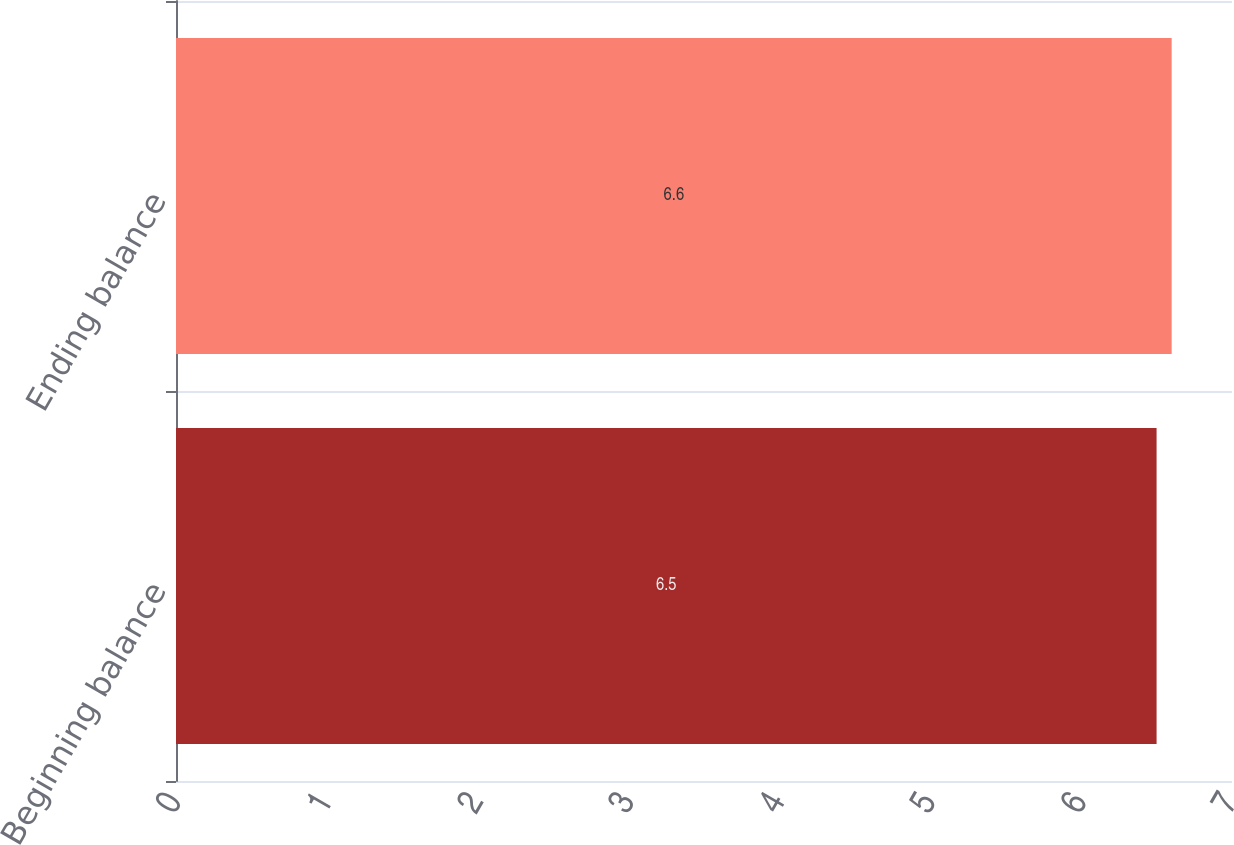<chart> <loc_0><loc_0><loc_500><loc_500><bar_chart><fcel>Beginning balance<fcel>Ending balance<nl><fcel>6.5<fcel>6.6<nl></chart> 